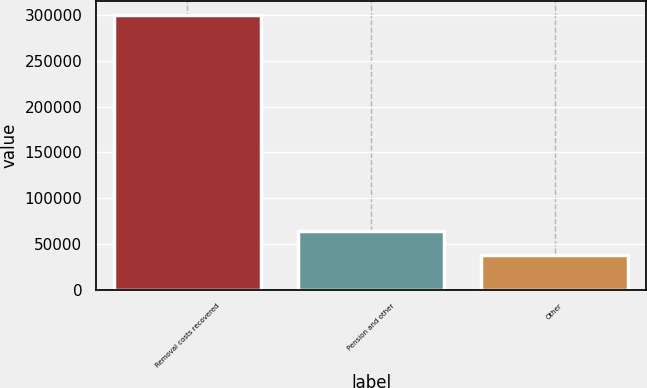Convert chart to OTSL. <chart><loc_0><loc_0><loc_500><loc_500><bar_chart><fcel>Removal costs recovered<fcel>Pension and other<fcel>Other<nl><fcel>300635<fcel>63735.2<fcel>37413<nl></chart> 